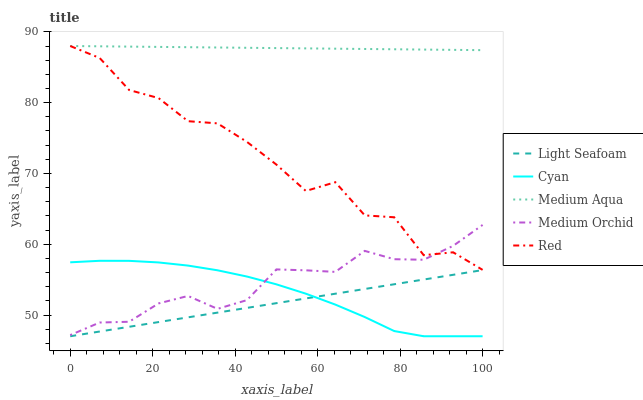Does Light Seafoam have the minimum area under the curve?
Answer yes or no. Yes. Does Medium Aqua have the maximum area under the curve?
Answer yes or no. Yes. Does Medium Orchid have the minimum area under the curve?
Answer yes or no. No. Does Medium Orchid have the maximum area under the curve?
Answer yes or no. No. Is Light Seafoam the smoothest?
Answer yes or no. Yes. Is Red the roughest?
Answer yes or no. Yes. Is Medium Orchid the smoothest?
Answer yes or no. No. Is Medium Orchid the roughest?
Answer yes or no. No. Does Cyan have the lowest value?
Answer yes or no. Yes. Does Medium Orchid have the lowest value?
Answer yes or no. No. Does Red have the highest value?
Answer yes or no. Yes. Does Medium Orchid have the highest value?
Answer yes or no. No. Is Light Seafoam less than Medium Orchid?
Answer yes or no. Yes. Is Medium Aqua greater than Medium Orchid?
Answer yes or no. Yes. Does Red intersect Medium Orchid?
Answer yes or no. Yes. Is Red less than Medium Orchid?
Answer yes or no. No. Is Red greater than Medium Orchid?
Answer yes or no. No. Does Light Seafoam intersect Medium Orchid?
Answer yes or no. No. 